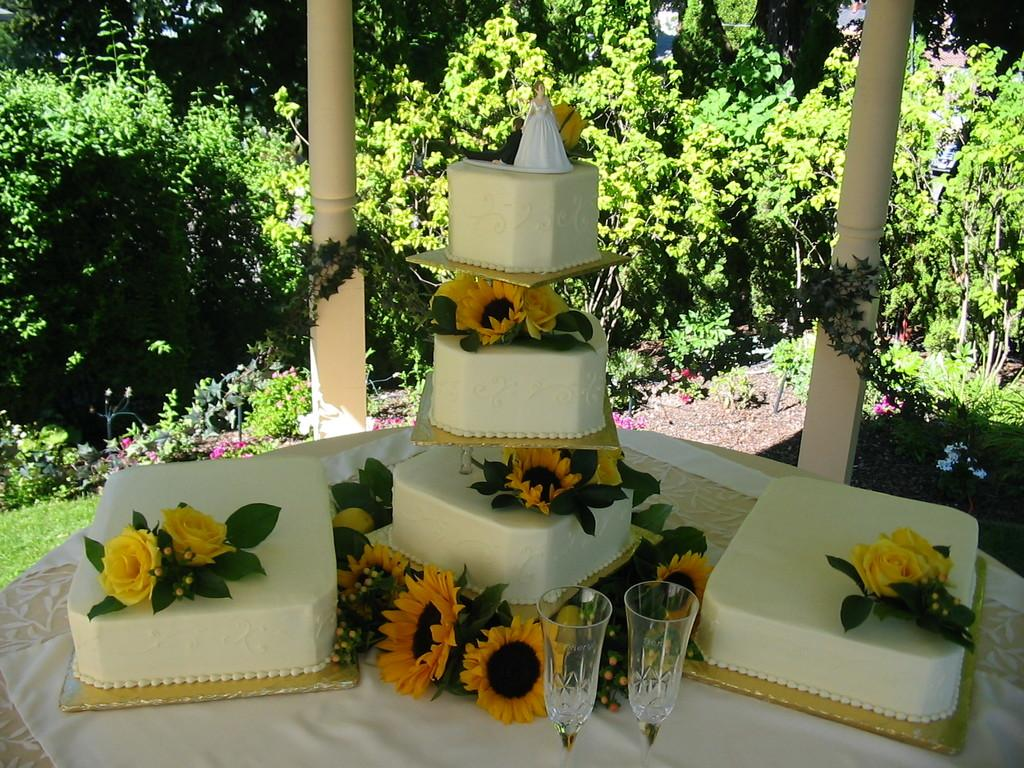What is the main object in the image? There is a table in the image. What is on the table? The table contains cakes, flowers, and glasses. Are there any plants visible in the image? Yes, there are plants in the image. What else can be seen in the image besides the table and plants? There are poles in the image. How many nails can be seen holding the table together in the image? There is no mention of nails in the image, and the table's construction is not visible. What type of mark can be seen on the table in the image? There is no mention of any marks on the table in the image. 